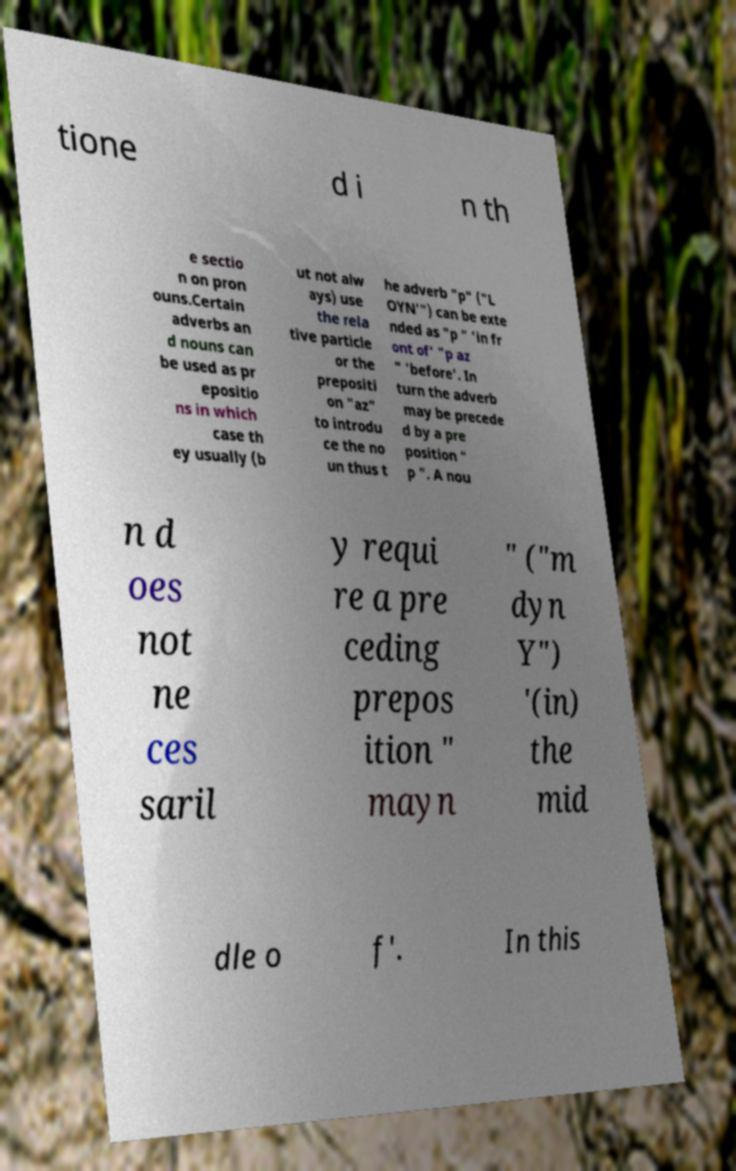Can you accurately transcribe the text from the provided image for me? tione d i n th e sectio n on pron ouns.Certain adverbs an d nouns can be used as pr epositio ns in which case th ey usually (b ut not alw ays) use the rela tive particle or the prepositi on "az" to introdu ce the no un thus t he adverb "p" ("L OYN'") can be exte nded as "p " 'in fr ont of' "p az " 'before'. In turn the adverb may be precede d by a pre position " p ". A nou n d oes not ne ces saril y requi re a pre ceding prepos ition " mayn " ("m dyn Y") '(in) the mid dle o f'. In this 